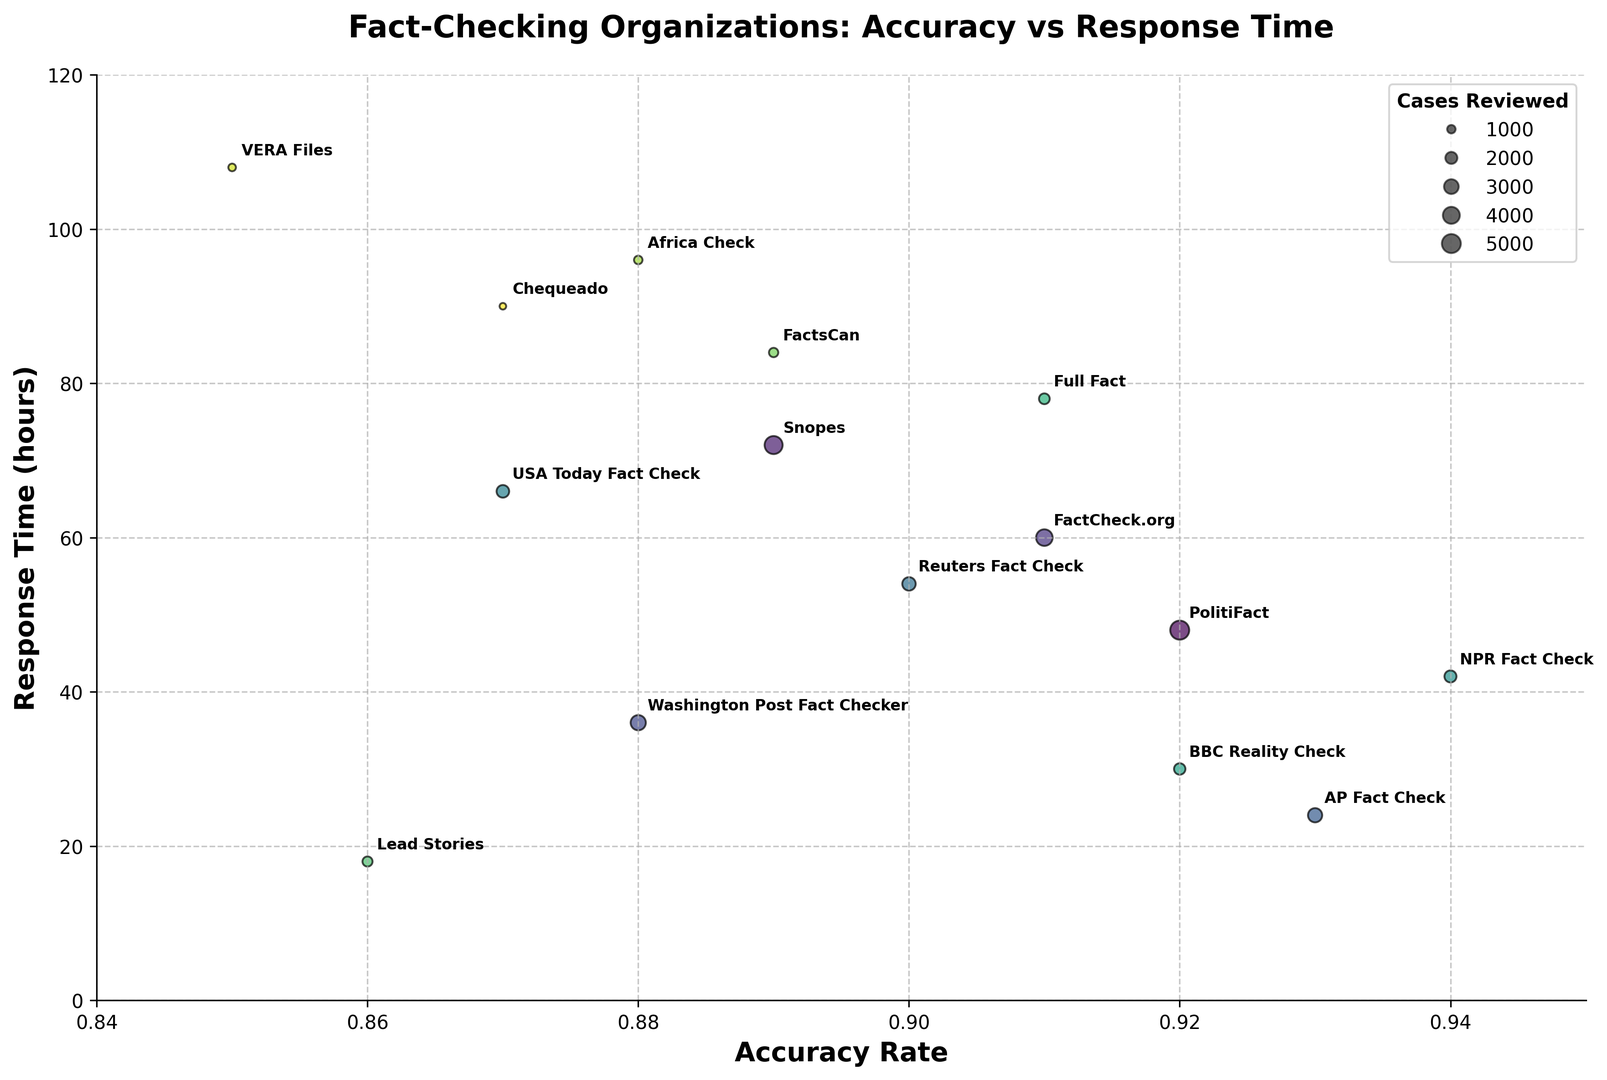What's the average accuracy rate of the top 3 organizations? To find the top 3 organizations by accuracy rate, look for the highest values which are NPR Fact Check (0.94), AP Fact Check (0.93), and PolitiFact/BBC Reality Check (both 0.92). Calculate the average of these four values: (0.94 + 0.93 + 0.92 + 0.92) / 4 = 0.9275
Answer: 0.9275 Which organization has the longest response time? Look at the y-axis values and identify the highest point, which corresponds to VERA Files with a response time of 108 hours
Answer: VERA Files Does PolitiFact have a higher accuracy rate than FactCheck.org? Compare the x-axis positions of the two organizations. PolitiFact is at 0.92 and FactCheck.org is at 0.91
Answer: Yes How many cases reviewed are there between the smallest and largest sized bubbles? Identify the bubble sizes from smallest to largest. VERA Files (800 cases) is the smallest, and PolitiFact (5000 cases) is the largest. Calculate the difference: 5000 - 800 = 4200
Answer: 4200 Which organization has the fastest response time? Identify the lowest value on the y-axis, which corresponds to Lead Stories with a response time of 18 hours
Answer: Lead Stories What is the color difference between Snopes and NPR Fact Check? Examine the colors of the bubbles. Since colors gradually change along the viridis color map, Snopes and NPR Fact Check are distinct due to their different positions along the spectrum. Snopes has a cooler (darker) hue, while NPR Fact Check has a relatively warmer (brighter) hue
Answer: Snopes - cooler, NPR Fact Check - warmer Is the median response time above or below 60 hours? List all response times and find the median value: [18, 24, 30, 36, 42, 48, 54, 60, 66, 72, 78, 84, 90, 96, 108]. The median response time is the 8th value, which is 60 hours
Answer: equal to 60 hours How do Reuters Fact Check and AP Fact Check compare in terms of response time? Compare their y-axis values. Reuters Fact Check has a response time of 54 hours, while AP Fact Check has a response time of 24 hours
Answer: Reuters Fact Check is slower Which organization has more cases reviewed, USA Today Fact Check or Washington Post Fact Checker? Compare the sizes of the bubbles. USA Today Fact Check reviewed 2200 cases, while Washington Post Fact Checker reviewed 3200 cases
Answer: Washington Post Fact Checker What's the combined accuracy rate of Lead Stories and Chequeado? Add their accuracy rates. Lead Stories has an accuracy rate of 0.86, and Chequeado has an accuracy rate of 0.87. The combined rate: 0.86 + 0.87 = 1.73
Answer: 1.73 